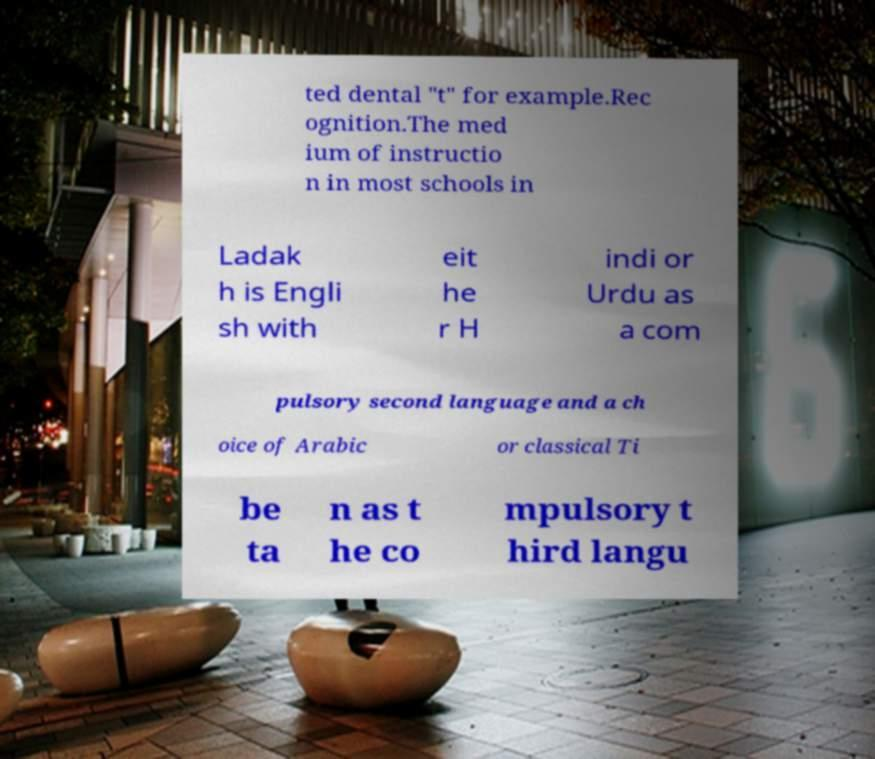I need the written content from this picture converted into text. Can you do that? ted dental "t" for example.Rec ognition.The med ium of instructio n in most schools in Ladak h is Engli sh with eit he r H indi or Urdu as a com pulsory second language and a ch oice of Arabic or classical Ti be ta n as t he co mpulsory t hird langu 